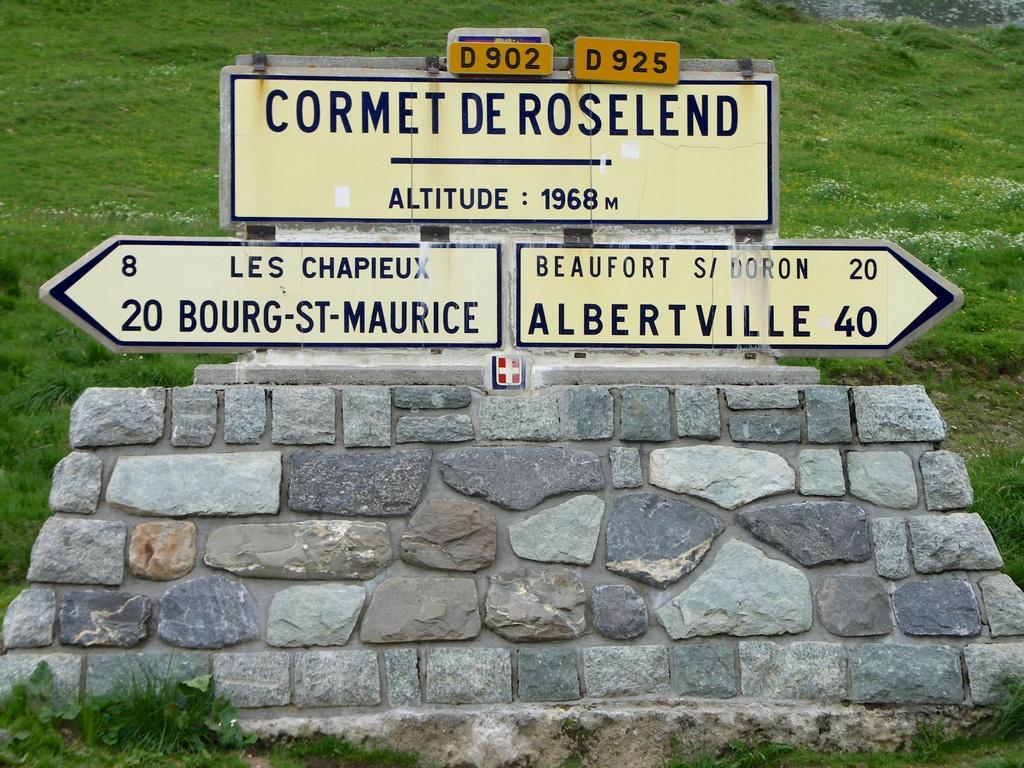<image>
Render a clear and concise summary of the photo. Cormet de roseland, bourg st maurice, and albertville wrote on top of bricks 